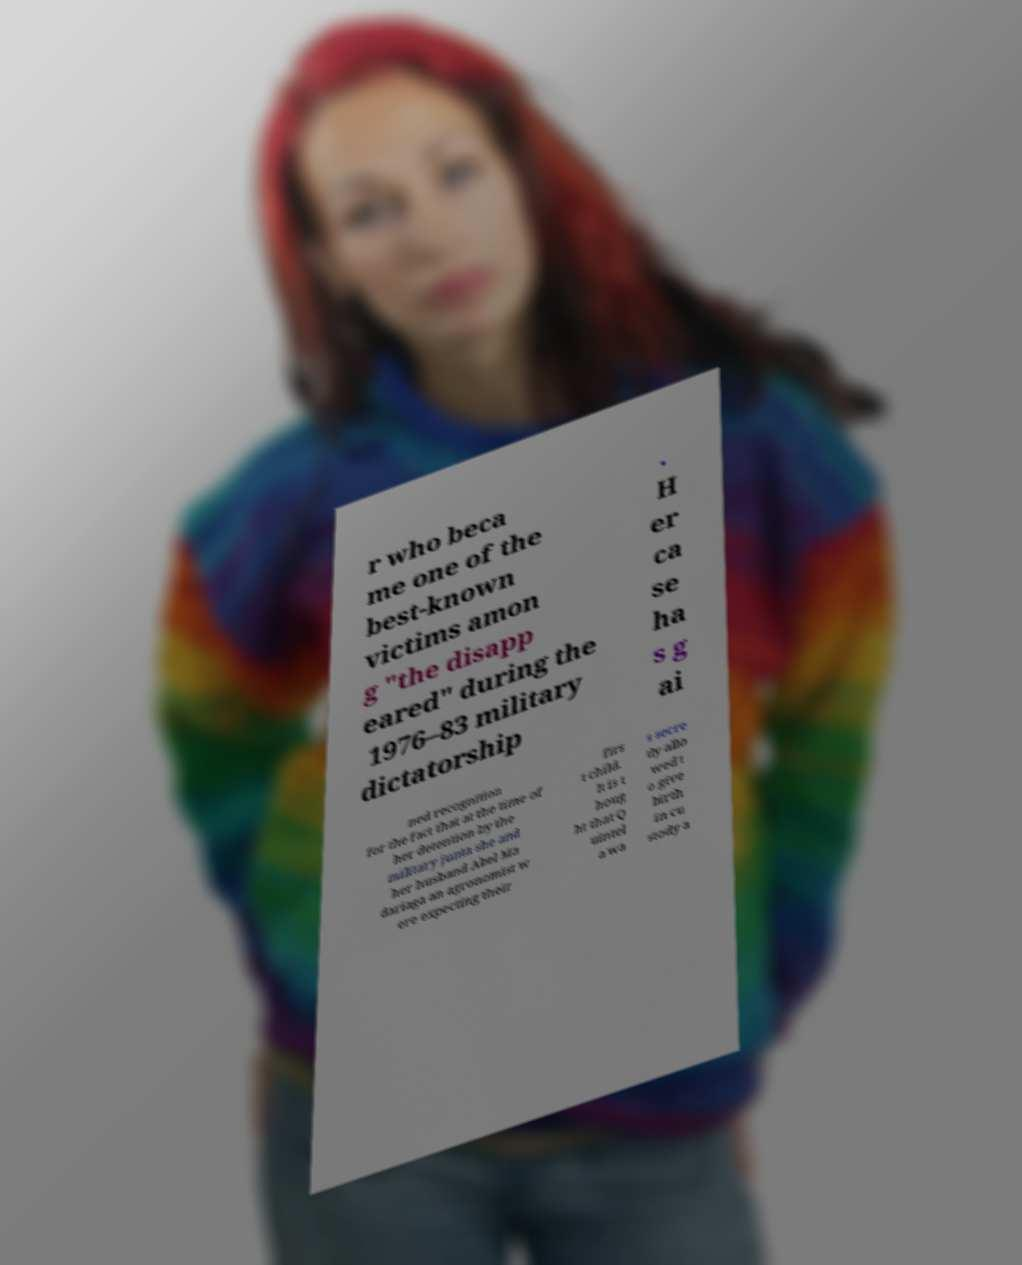Can you read and provide the text displayed in the image?This photo seems to have some interesting text. Can you extract and type it out for me? r who beca me one of the best-known victims amon g "the disapp eared" during the 1976–83 military dictatorship . H er ca se ha s g ai ned recognition for the fact that at the time of her detention by the military junta she and her husband Abel Ma dariaga an agronomist w ere expecting their firs t child. It is t houg ht that Q uintel a wa s secre tly allo wed t o give birth in cu stody a 